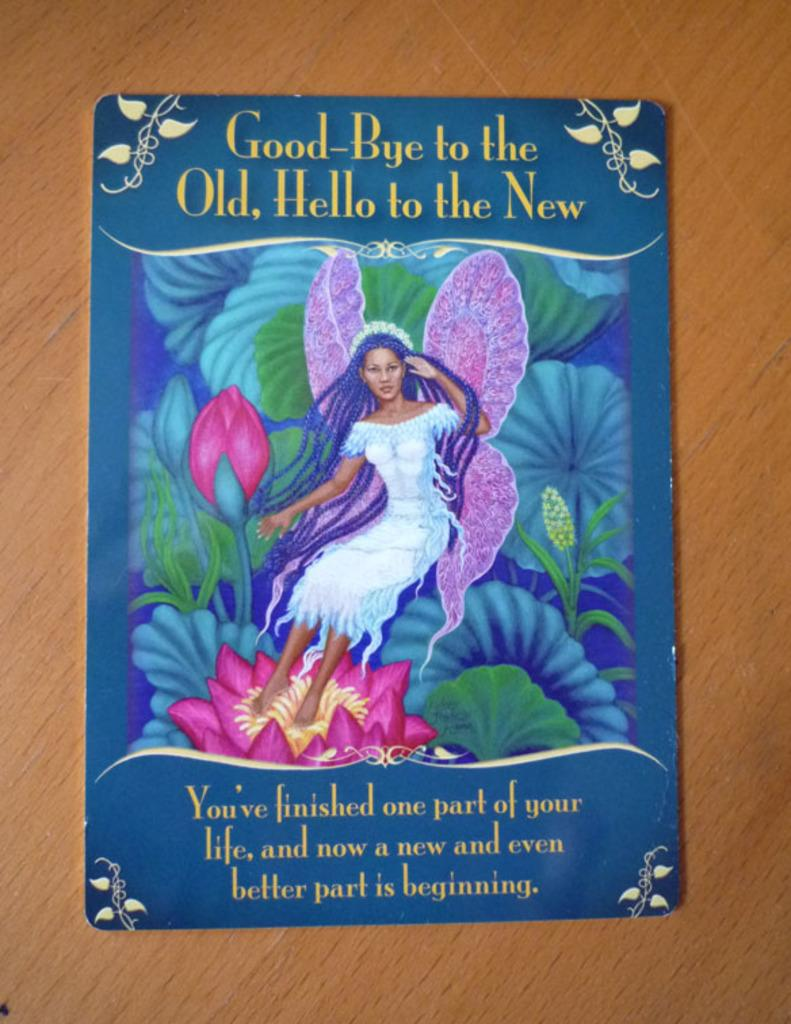What type of visual is the image in question? The image is a poster. What can be found on the poster besides the image? There is text written on the poster. What is the main subject of the image on the poster? There is an image of a girl on the poster. What is the girl doing in the image? The girl is standing on a flower in the image. What other elements are present in the image? There are leaves depicted in the image. What is the comparison between the tank and the girl in the image? There is no tank present in the image, so it is not possible to make a comparison between the two. 